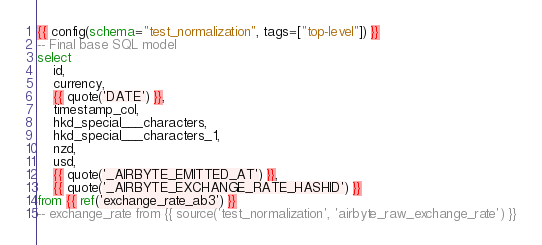Convert code to text. <code><loc_0><loc_0><loc_500><loc_500><_SQL_>{{ config(schema="test_normalization", tags=["top-level"]) }}
-- Final base SQL model
select
    id,
    currency,
    {{ quote('DATE') }},
    timestamp_col,
    hkd_special___characters,
    hkd_special___characters_1,
    nzd,
    usd,
    {{ quote('_AIRBYTE_EMITTED_AT') }},
    {{ quote('_AIRBYTE_EXCHANGE_RATE_HASHID') }}
from {{ ref('exchange_rate_ab3') }}
-- exchange_rate from {{ source('test_normalization', 'airbyte_raw_exchange_rate') }}

</code> 